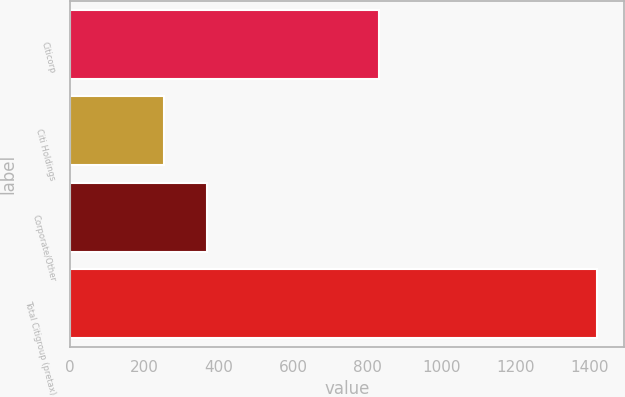<chart> <loc_0><loc_0><loc_500><loc_500><bar_chart><fcel>Citicorp<fcel>Citi Holdings<fcel>Corporate/Other<fcel>Total Citigroup (pretax)<nl><fcel>832<fcel>252<fcel>368.8<fcel>1420<nl></chart> 